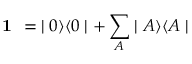Convert formula to latex. <formula><loc_0><loc_0><loc_500><loc_500>1 = \, | 0 \rangle \langle 0 | + \sum _ { A } | A \rangle \langle A |</formula> 